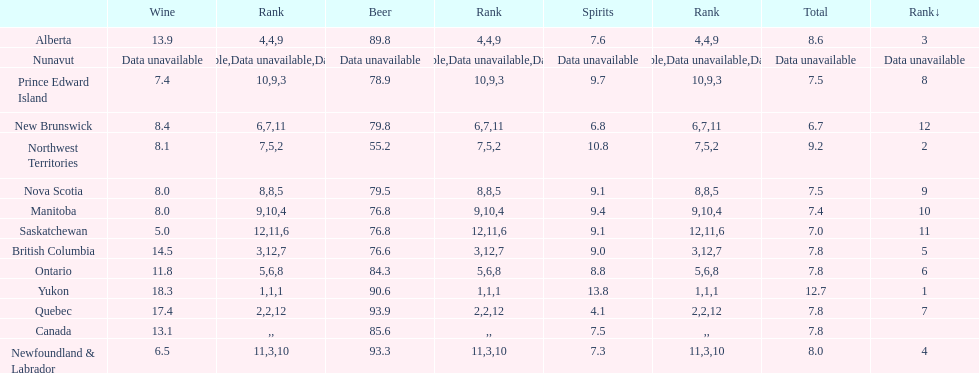How many litres do individuals in yukon consume in spirits per year? 12.7. 